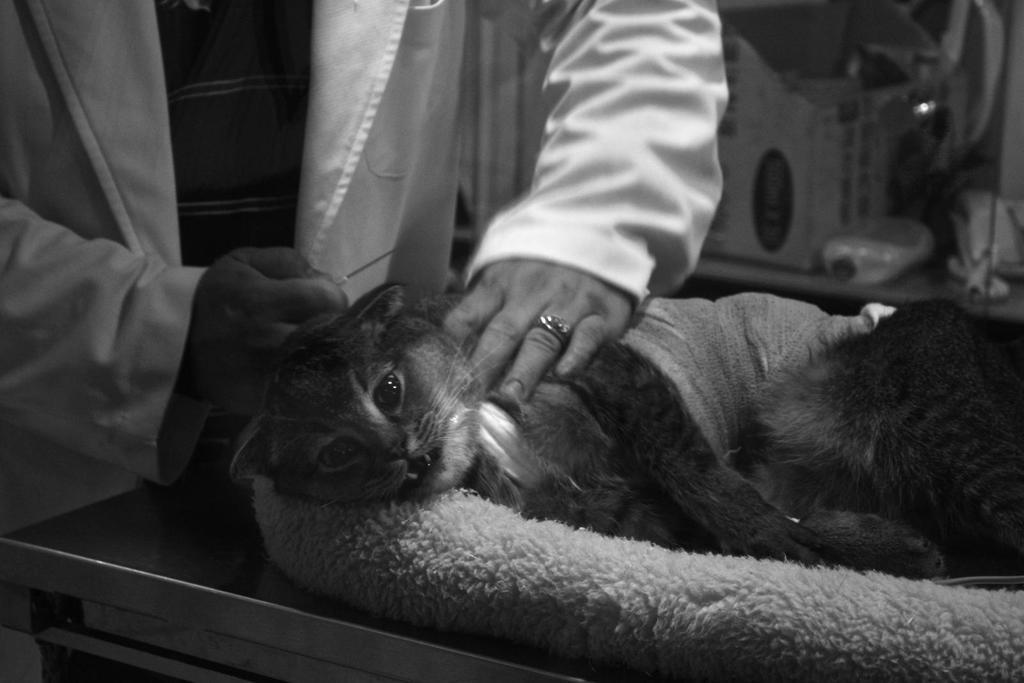What animal is lying on the table in the image? There is a cat lying on the table in the image. Can you describe the person in the background of the image? The person in the background of the image is holding an injection in his hands. What type of insurance does the maid have in the image? There is no maid present in the image, and therefore no insurance can be discussed. 